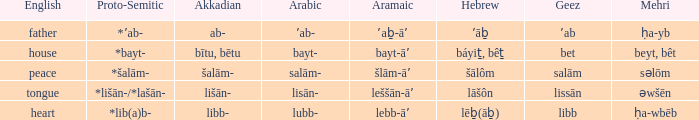If in english it is heart, what is it in hebrew? Lēḇ(āḇ). 